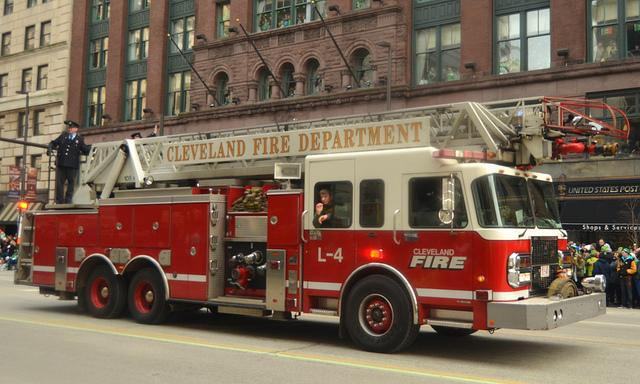What state is this city in? Please explain your reasoning. ohio. The word above fire on the truck is cleveland. this city is in the united states of america but is not in illinois or new york. 